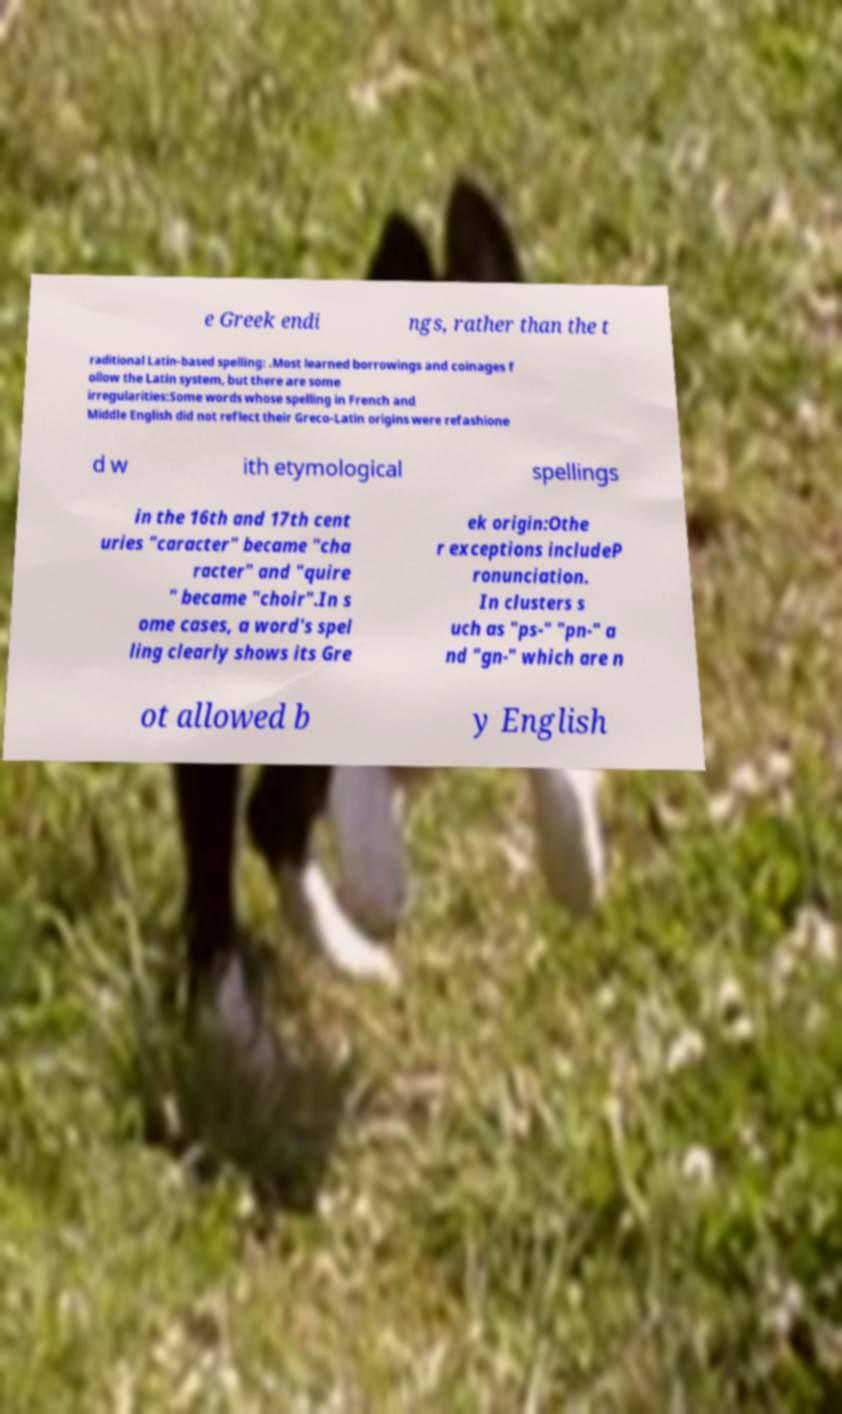Please read and relay the text visible in this image. What does it say? e Greek endi ngs, rather than the t raditional Latin-based spelling: .Most learned borrowings and coinages f ollow the Latin system, but there are some irregularities:Some words whose spelling in French and Middle English did not reflect their Greco-Latin origins were refashione d w ith etymological spellings in the 16th and 17th cent uries "caracter" became "cha racter" and "quire " became "choir".In s ome cases, a word's spel ling clearly shows its Gre ek origin:Othe r exceptions includeP ronunciation. In clusters s uch as "ps-" "pn-" a nd "gn-" which are n ot allowed b y English 